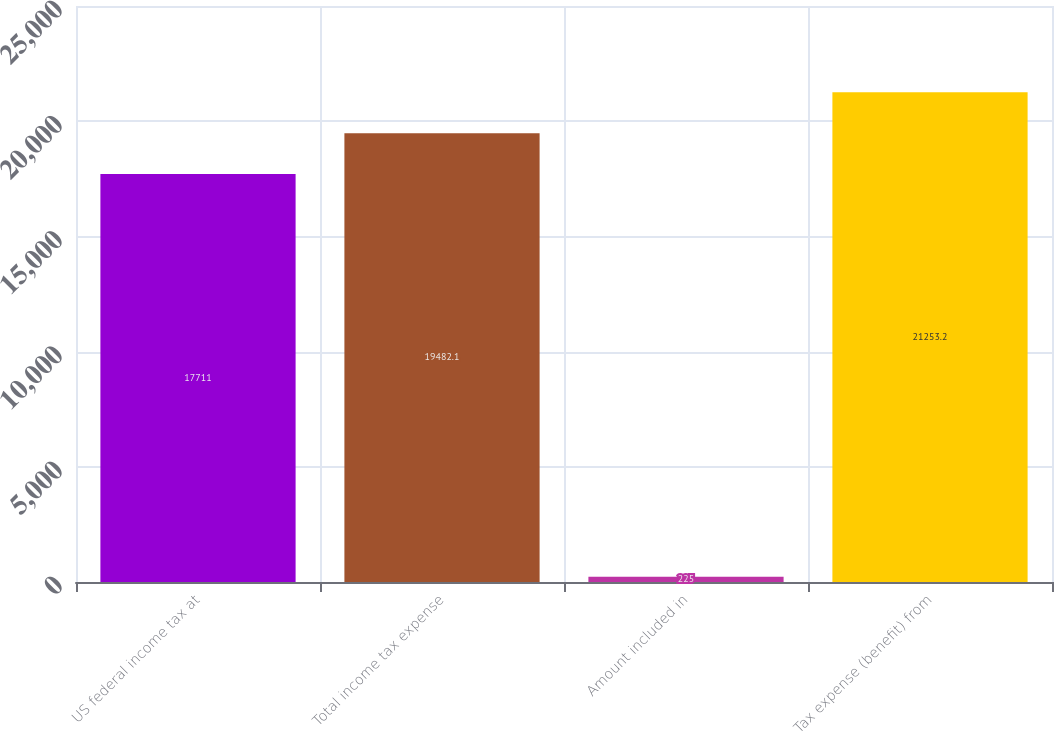Convert chart to OTSL. <chart><loc_0><loc_0><loc_500><loc_500><bar_chart><fcel>US federal income tax at<fcel>Total income tax expense<fcel>Amount included in<fcel>Tax expense (benefit) from<nl><fcel>17711<fcel>19482.1<fcel>225<fcel>21253.2<nl></chart> 